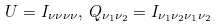<formula> <loc_0><loc_0><loc_500><loc_500>U = I _ { \nu \nu \nu \nu } , \, Q _ { \nu _ { 1 } \nu _ { 2 } } = I _ { \nu _ { 1 } \nu _ { 2 } \nu _ { 1 } \nu _ { 2 } }</formula> 